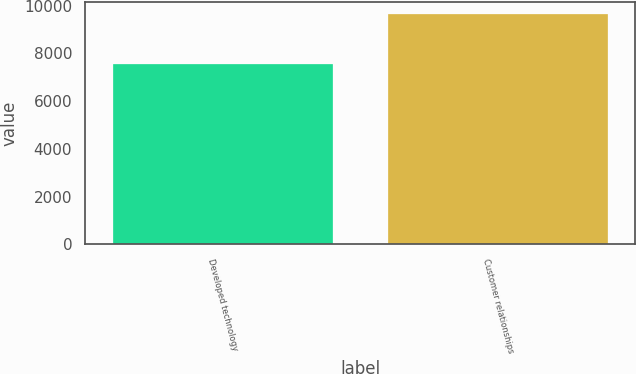Convert chart. <chart><loc_0><loc_0><loc_500><loc_500><bar_chart><fcel>Developed technology<fcel>Customer relationships<nl><fcel>7533<fcel>9650<nl></chart> 